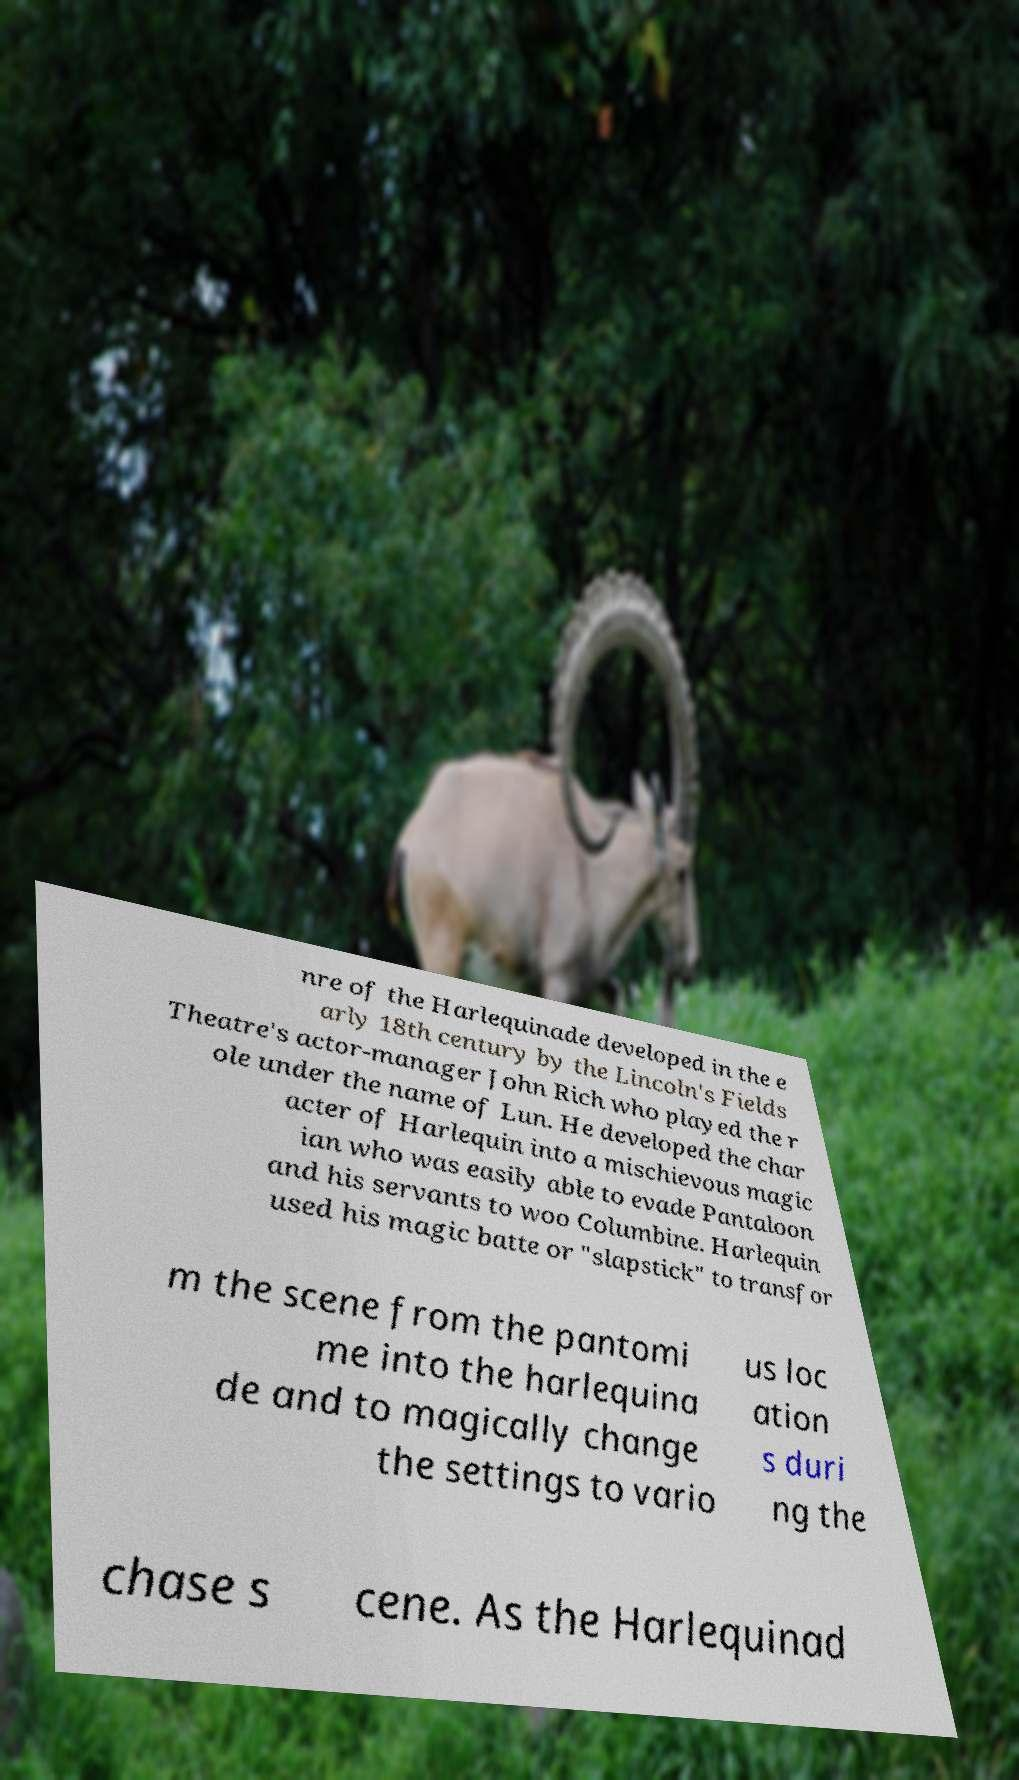Can you read and provide the text displayed in the image?This photo seems to have some interesting text. Can you extract and type it out for me? nre of the Harlequinade developed in the e arly 18th century by the Lincoln's Fields Theatre's actor-manager John Rich who played the r ole under the name of Lun. He developed the char acter of Harlequin into a mischievous magic ian who was easily able to evade Pantaloon and his servants to woo Columbine. Harlequin used his magic batte or "slapstick" to transfor m the scene from the pantomi me into the harlequina de and to magically change the settings to vario us loc ation s duri ng the chase s cene. As the Harlequinad 